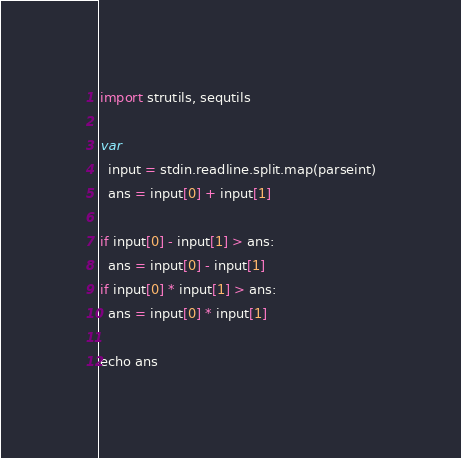Convert code to text. <code><loc_0><loc_0><loc_500><loc_500><_Nim_>import strutils, sequtils

var
  input = stdin.readline.split.map(parseint)
  ans = input[0] + input[1]

if input[0] - input[1] > ans:
  ans = input[0] - input[1]
if input[0] * input[1] > ans:
  ans = input[0] * input[1]

echo ans
</code> 